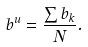Convert formula to latex. <formula><loc_0><loc_0><loc_500><loc_500>b ^ { u } = \frac { \sum { b _ { k } } } { N } .</formula> 